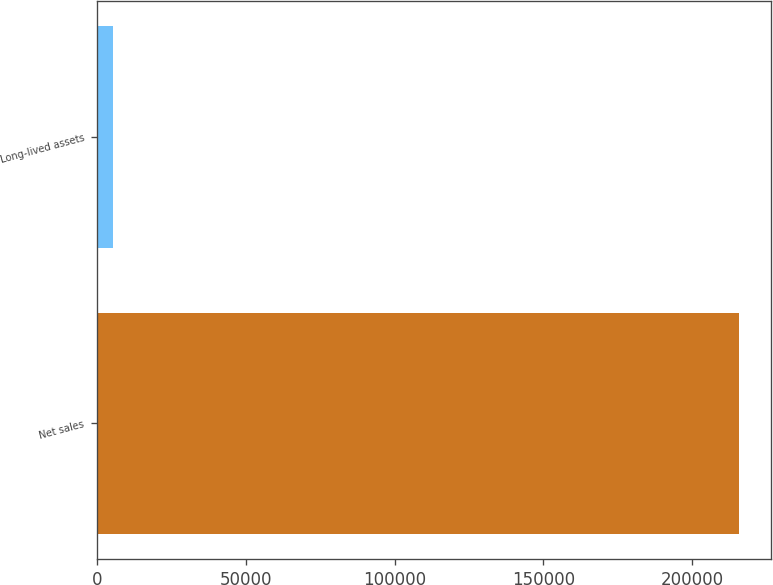<chart> <loc_0><loc_0><loc_500><loc_500><bar_chart><fcel>Net sales<fcel>Long-lived assets<nl><fcel>215911<fcel>5377<nl></chart> 